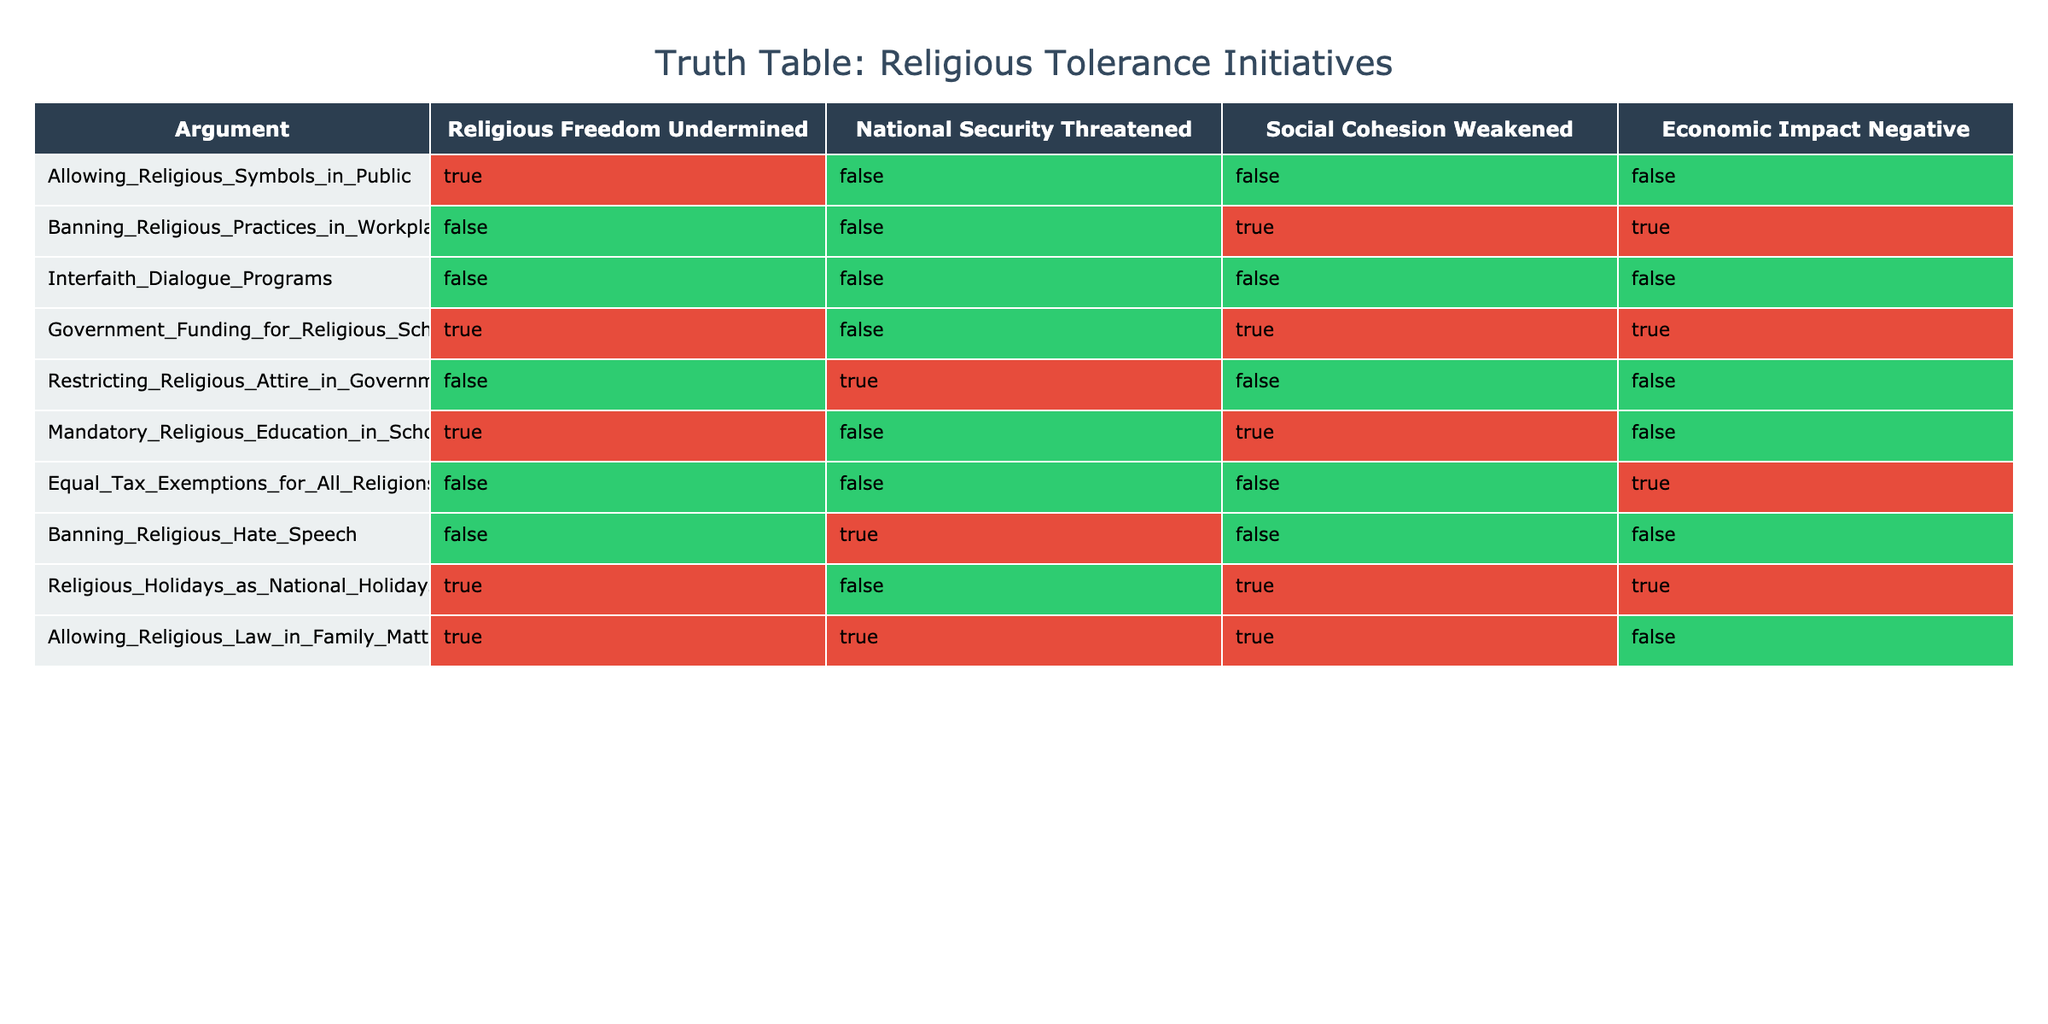What are the arguments that undermine religious freedom? By examining the first column of the table, we can identify the rows where the value for "Religious Freedom Undermined" is true. These arguments are: "Allowing Religious Symbols in Public," "Government Funding for Religious Schools," "Mandatory Religious Education in Schools," and "Allowing Religious Law in Family Matters."
Answer: "Allowing Religious Symbols in Public," "Government Funding for Religious Schools," "Mandatory Religious Education in Schools," "Allowing Religious Law in Family Matters." Which argument poses a national security threat? Looking at the second column for "National Security Threatened," we can find the arguments that are marked as true. These are: "Restricting Religious Attire in Government Jobs" and "Allowing Religious Law in Family Matters."
Answer: "Restricting Religious Attire in Government Jobs," "Allowing Religious Law in Family Matters." How many arguments weaken social cohesion? To find how many arguments weaken social cohesion, we count the number of rows where "Social Cohesion Weakened" is true. Only "Banning Religious Practices in Workplaces," "Government Funding for Religious Schools," "Mandatory Religious Education in Schools," and "Allowing Religious Law in Family Matters" have this characteristic, totaling four arguments.
Answer: 4 Are there any arguments that negatively impact the economy? By examining the last column titled "Economic Impact Negative," we can determine which arguments are marked true. These include: "Banning Religious Practices in Workplaces," "Government Funding for Religious Schools," "Equal Tax Exemptions for All Religions," and "Religious Holidays as National Holidays."
Answer: "Banning Religious Practices in Workplaces," "Government Funding for Religious Schools," "Equal Tax Exemptions for All Religions," "Religious Holidays as National Holidays." Which argument is the only one that does not affect any of the categories? From the table, we can see that "Interfaith Dialogue Programs" is the only argument with all categories marked as false, indicating it does not have any negative impact on religious freedom, national security, social cohesion, or the economy.
Answer: "Interfaith Dialogue Programs" Which two arguments both threaten national security and weaken social cohesion? By looking at the columns for "National Security Threatened" and "Social Cohesion Weakened," we identify "Allowing Religious Law in Family Matters" as a common argument. Upon re-examining, no other arguments share both true values in these columns. Thus the answer is "Allowing Religious Law in Family Matters" alone.
Answer: "Allowing Religious Law in Family Matters" 